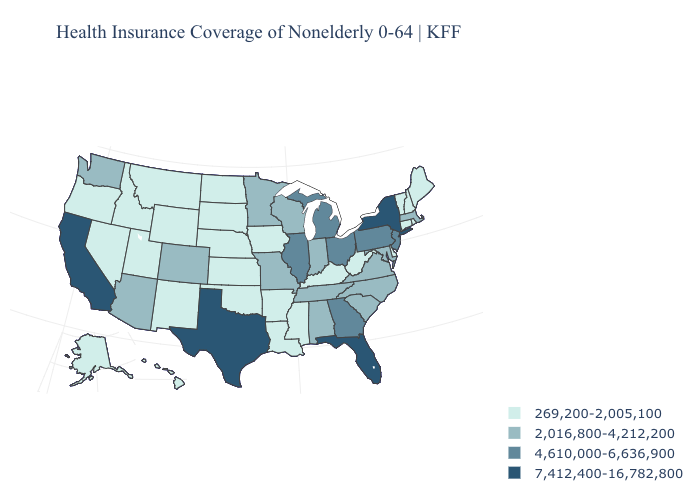Among the states that border Illinois , does Iowa have the lowest value?
Quick response, please. Yes. Does Massachusetts have the highest value in the Northeast?
Write a very short answer. No. Name the states that have a value in the range 2,016,800-4,212,200?
Be succinct. Alabama, Arizona, Colorado, Indiana, Maryland, Massachusetts, Minnesota, Missouri, North Carolina, South Carolina, Tennessee, Virginia, Washington, Wisconsin. Name the states that have a value in the range 7,412,400-16,782,800?
Answer briefly. California, Florida, New York, Texas. Name the states that have a value in the range 4,610,000-6,636,900?
Answer briefly. Georgia, Illinois, Michigan, New Jersey, Ohio, Pennsylvania. Among the states that border South Dakota , does Wyoming have the highest value?
Be succinct. No. What is the highest value in states that border Nebraska?
Write a very short answer. 2,016,800-4,212,200. Among the states that border Missouri , which have the lowest value?
Give a very brief answer. Arkansas, Iowa, Kansas, Kentucky, Nebraska, Oklahoma. Among the states that border New Hampshire , which have the lowest value?
Quick response, please. Maine, Vermont. Does New Hampshire have the lowest value in the USA?
Answer briefly. Yes. Name the states that have a value in the range 4,610,000-6,636,900?
Concise answer only. Georgia, Illinois, Michigan, New Jersey, Ohio, Pennsylvania. Does California have the highest value in the USA?
Keep it brief. Yes. What is the value of Kentucky?
Concise answer only. 269,200-2,005,100. Does the map have missing data?
Answer briefly. No. What is the highest value in states that border New Hampshire?
Short answer required. 2,016,800-4,212,200. 